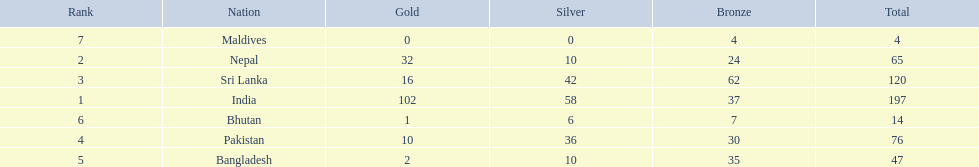What are the totals of medals one in each country? 197, 65, 120, 76, 47, 14, 4. Which of these totals are less than 10? 4. Who won this number of medals? Maldives. 